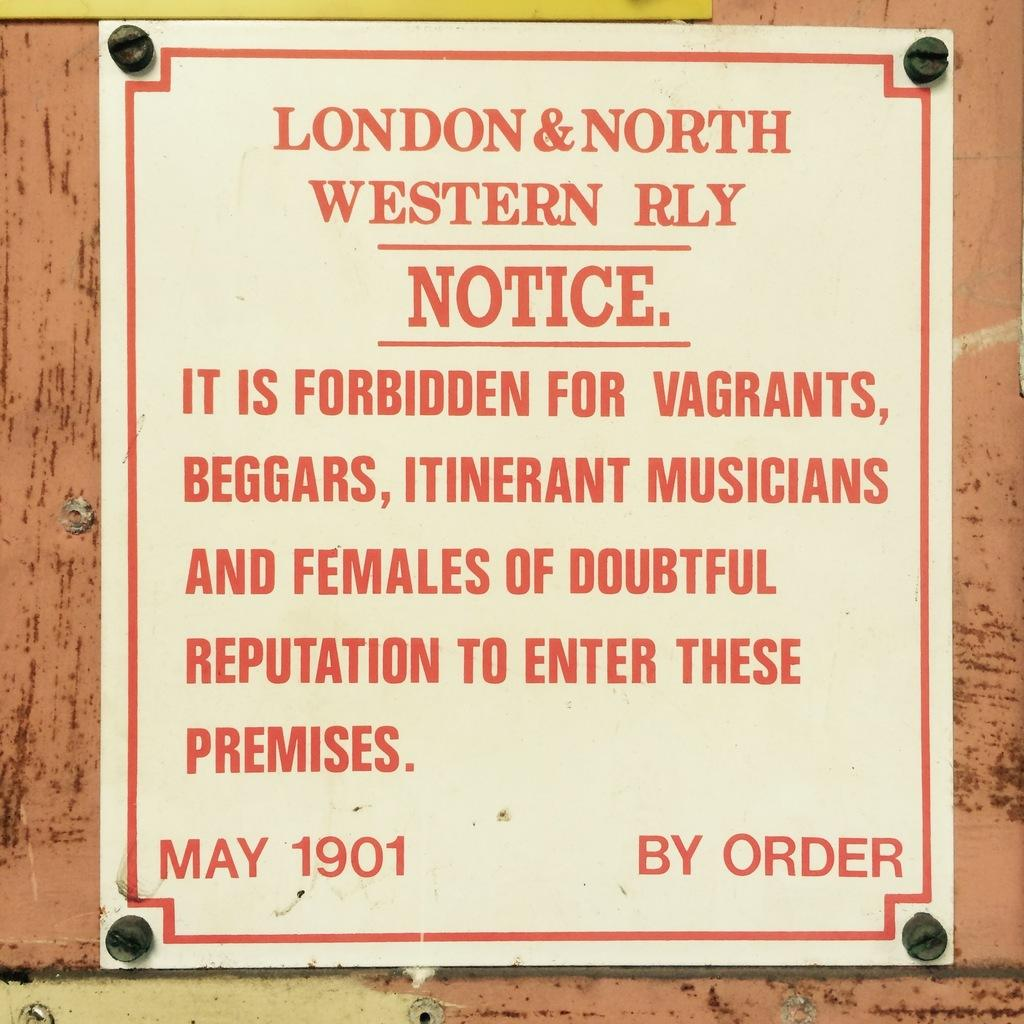<image>
Create a compact narrative representing the image presented. A notice by London & North Western RLY. 